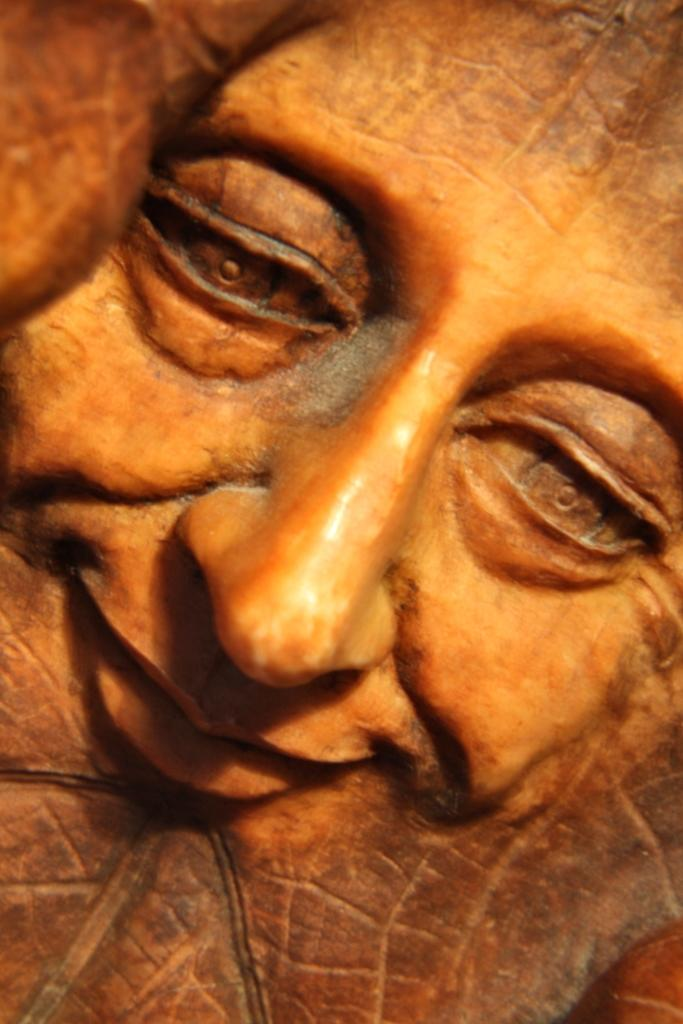What is the main subject of the image? There is a sculpture in the image. Can you describe the sculpture? The sculpture is of a face. What colors are used in the sculpture? The sculpture has brown and orange colors. What type of watch is the face wearing in the image? There is no watch present in the image; the sculpture is of a face without any accessories. 